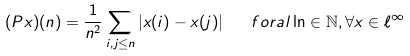<formula> <loc_0><loc_0><loc_500><loc_500>( P x ) ( n ) = \frac { 1 } { n ^ { 2 } } \sum _ { i , j \leq n } | x ( i ) - x ( j ) | \quad f o r a l \ln \in \mathbb { N } , \forall x \in \ell ^ { \infty }</formula> 